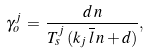<formula> <loc_0><loc_0><loc_500><loc_500>\gamma _ { o } ^ { j } \, = \, \frac { d \, n } { T _ { s } ^ { j } \, ( k _ { j } \, \overline { l } \, n + d ) } ,</formula> 